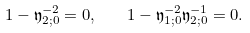<formula> <loc_0><loc_0><loc_500><loc_500>1 - \mathfrak y _ { 2 ; 0 } ^ { - 2 } = 0 , \quad 1 - \mathfrak y _ { 1 ; 0 } ^ { - 2 } \mathfrak y _ { 2 ; 0 } ^ { - 1 } = 0 .</formula> 